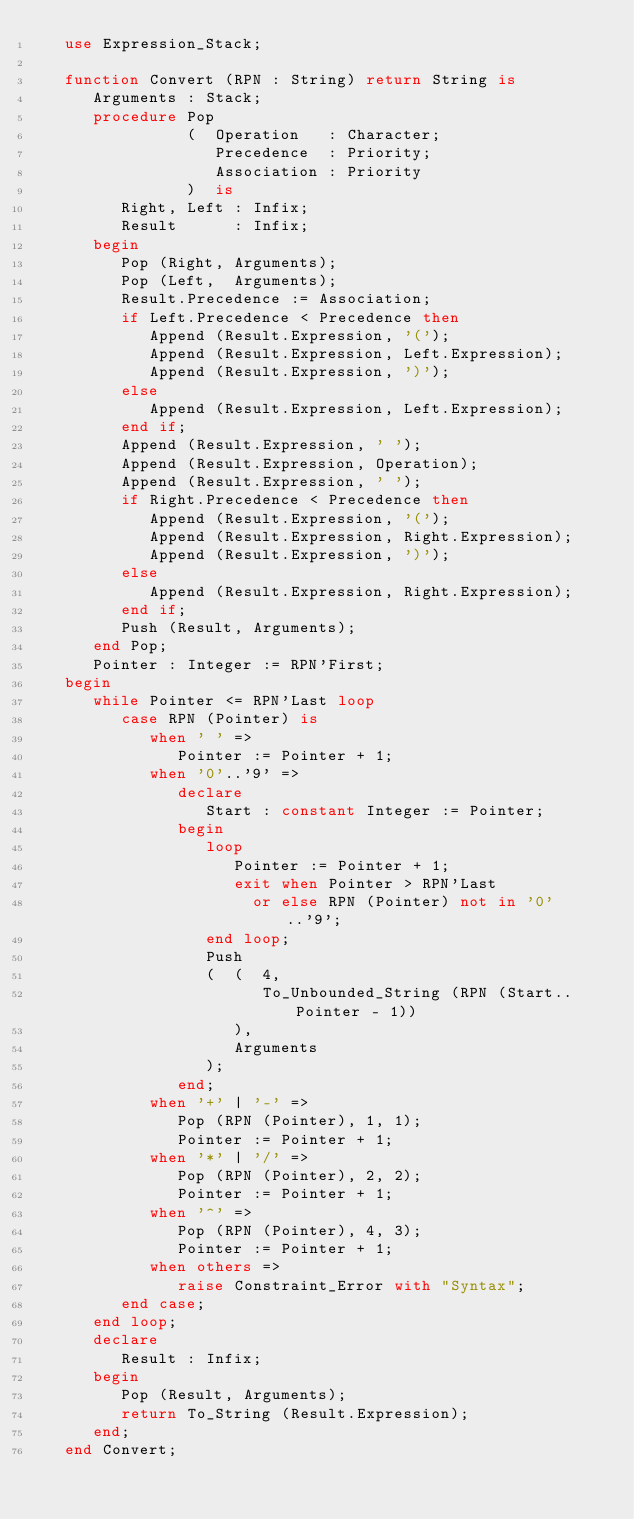Convert code to text. <code><loc_0><loc_0><loc_500><loc_500><_Ada_>   use Expression_Stack;

   function Convert (RPN : String) return String is
      Arguments : Stack;
      procedure Pop
                (  Operation   : Character;
                   Precedence  : Priority;
                   Association : Priority
                )  is
         Right, Left : Infix;
         Result      : Infix;
      begin
         Pop (Right, Arguments);
         Pop (Left,  Arguments);
         Result.Precedence := Association;
         if Left.Precedence < Precedence then
            Append (Result.Expression, '(');
            Append (Result.Expression, Left.Expression);
            Append (Result.Expression, ')');
         else
            Append (Result.Expression, Left.Expression);
         end if;
         Append (Result.Expression, ' ');
         Append (Result.Expression, Operation);
         Append (Result.Expression, ' ');
         if Right.Precedence < Precedence then
            Append (Result.Expression, '(');
            Append (Result.Expression, Right.Expression);
            Append (Result.Expression, ')');
         else
            Append (Result.Expression, Right.Expression);
         end if;
         Push (Result, Arguments);
      end Pop;
      Pointer : Integer := RPN'First;
   begin
      while Pointer <= RPN'Last loop
         case RPN (Pointer) is
            when ' ' =>
               Pointer := Pointer + 1;
            when '0'..'9' =>
               declare
                  Start : constant Integer := Pointer;
               begin
                  loop
                     Pointer := Pointer + 1;
                     exit when Pointer > RPN'Last
                       or else RPN (Pointer) not in '0'..'9';
                  end loop;
                  Push
                  (  (  4,
                        To_Unbounded_String (RPN (Start..Pointer - 1))
                     ),
                     Arguments
                  );
               end;
            when '+' | '-' =>
               Pop (RPN (Pointer), 1, 1);
               Pointer := Pointer + 1;
            when '*' | '/' =>
               Pop (RPN (Pointer), 2, 2);
               Pointer := Pointer + 1;
            when '^' =>
               Pop (RPN (Pointer), 4, 3);
               Pointer := Pointer + 1;
            when others =>
               raise Constraint_Error with "Syntax";
         end case;
      end loop;
      declare
         Result : Infix;
      begin
         Pop (Result, Arguments);
         return To_String (Result.Expression);
      end;
   end Convert;
</code> 